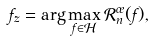Convert formula to latex. <formula><loc_0><loc_0><loc_500><loc_500>f _ { z } = \arg \max _ { f \in \mathcal { H } } \mathcal { R } _ { n } ^ { \sigma } ( f ) ,</formula> 